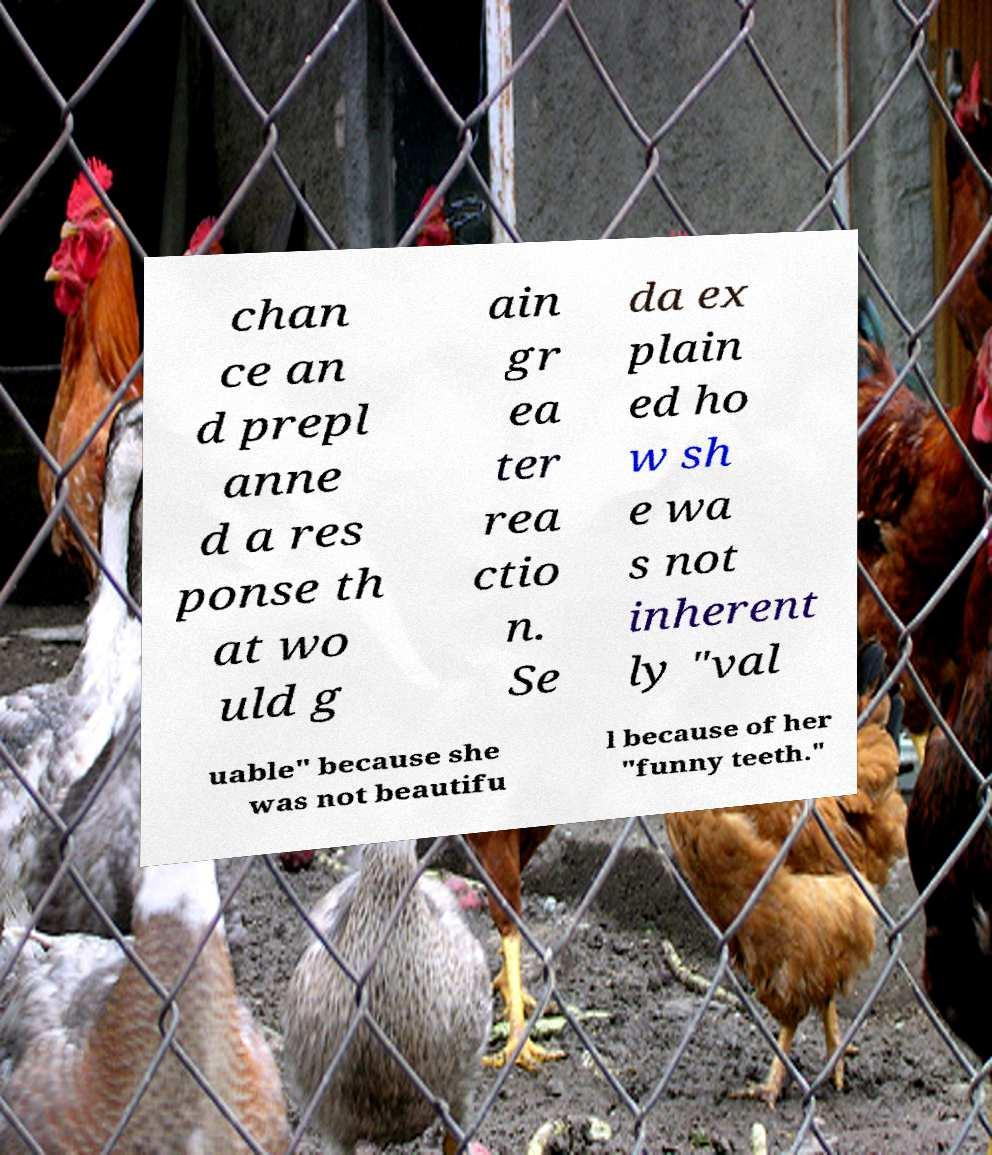There's text embedded in this image that I need extracted. Can you transcribe it verbatim? chan ce an d prepl anne d a res ponse th at wo uld g ain gr ea ter rea ctio n. Se da ex plain ed ho w sh e wa s not inherent ly "val uable" because she was not beautifu l because of her "funny teeth." 